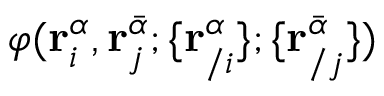Convert formula to latex. <formula><loc_0><loc_0><loc_500><loc_500>\varphi ( r _ { i } ^ { \alpha } , r _ { j } ^ { \bar { \alpha } } ; \{ r _ { / i } ^ { \alpha } \} ; \{ r _ { / j } ^ { \bar { \alpha } } \} )</formula> 